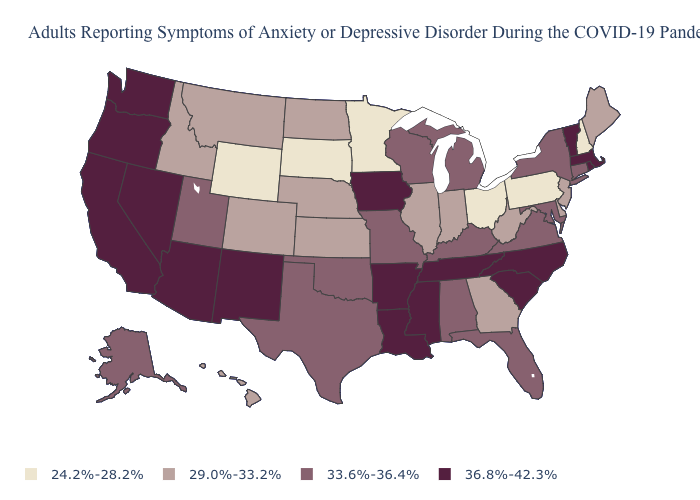Name the states that have a value in the range 33.6%-36.4%?
Be succinct. Alabama, Alaska, Connecticut, Florida, Kentucky, Maryland, Michigan, Missouri, New York, Oklahoma, Texas, Utah, Virginia, Wisconsin. Name the states that have a value in the range 29.0%-33.2%?
Short answer required. Colorado, Delaware, Georgia, Hawaii, Idaho, Illinois, Indiana, Kansas, Maine, Montana, Nebraska, New Jersey, North Dakota, West Virginia. Name the states that have a value in the range 24.2%-28.2%?
Quick response, please. Minnesota, New Hampshire, Ohio, Pennsylvania, South Dakota, Wyoming. What is the value of Florida?
Be succinct. 33.6%-36.4%. What is the value of Indiana?
Concise answer only. 29.0%-33.2%. Which states have the lowest value in the Northeast?
Concise answer only. New Hampshire, Pennsylvania. Name the states that have a value in the range 29.0%-33.2%?
Short answer required. Colorado, Delaware, Georgia, Hawaii, Idaho, Illinois, Indiana, Kansas, Maine, Montana, Nebraska, New Jersey, North Dakota, West Virginia. Name the states that have a value in the range 33.6%-36.4%?
Quick response, please. Alabama, Alaska, Connecticut, Florida, Kentucky, Maryland, Michigan, Missouri, New York, Oklahoma, Texas, Utah, Virginia, Wisconsin. Among the states that border South Dakota , does Iowa have the highest value?
Be succinct. Yes. Name the states that have a value in the range 33.6%-36.4%?
Keep it brief. Alabama, Alaska, Connecticut, Florida, Kentucky, Maryland, Michigan, Missouri, New York, Oklahoma, Texas, Utah, Virginia, Wisconsin. What is the value of Idaho?
Quick response, please. 29.0%-33.2%. What is the value of Arizona?
Quick response, please. 36.8%-42.3%. Among the states that border North Carolina , does Georgia have the lowest value?
Write a very short answer. Yes. Which states have the lowest value in the MidWest?
Concise answer only. Minnesota, Ohio, South Dakota. Among the states that border North Carolina , does Georgia have the lowest value?
Write a very short answer. Yes. 